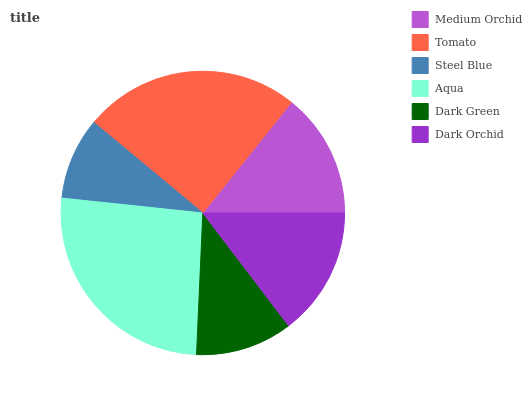Is Steel Blue the minimum?
Answer yes or no. Yes. Is Aqua the maximum?
Answer yes or no. Yes. Is Tomato the minimum?
Answer yes or no. No. Is Tomato the maximum?
Answer yes or no. No. Is Tomato greater than Medium Orchid?
Answer yes or no. Yes. Is Medium Orchid less than Tomato?
Answer yes or no. Yes. Is Medium Orchid greater than Tomato?
Answer yes or no. No. Is Tomato less than Medium Orchid?
Answer yes or no. No. Is Dark Orchid the high median?
Answer yes or no. Yes. Is Medium Orchid the low median?
Answer yes or no. Yes. Is Steel Blue the high median?
Answer yes or no. No. Is Dark Orchid the low median?
Answer yes or no. No. 